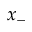<formula> <loc_0><loc_0><loc_500><loc_500>x _ { - }</formula> 